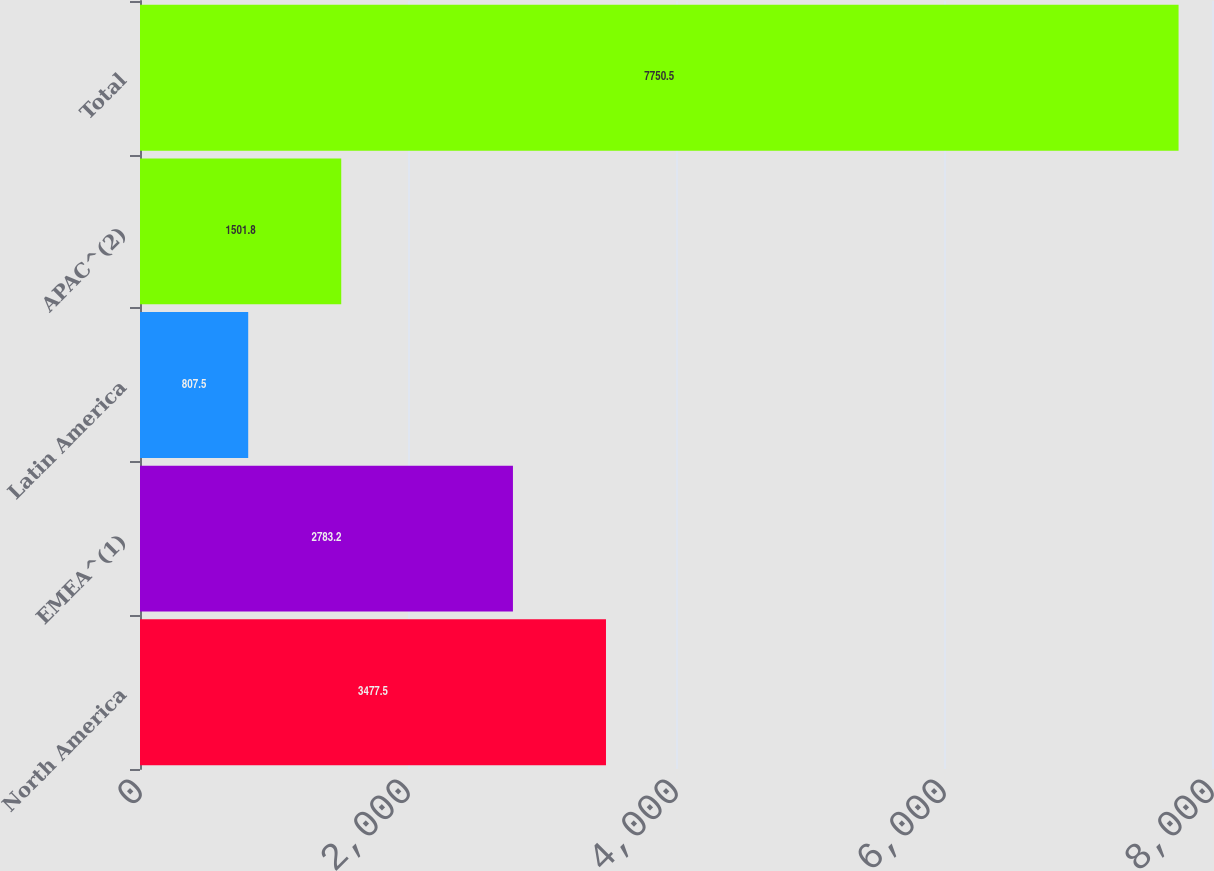<chart> <loc_0><loc_0><loc_500><loc_500><bar_chart><fcel>North America<fcel>EMEA^(1)<fcel>Latin America<fcel>APAC^(2)<fcel>Total<nl><fcel>3477.5<fcel>2783.2<fcel>807.5<fcel>1501.8<fcel>7750.5<nl></chart> 